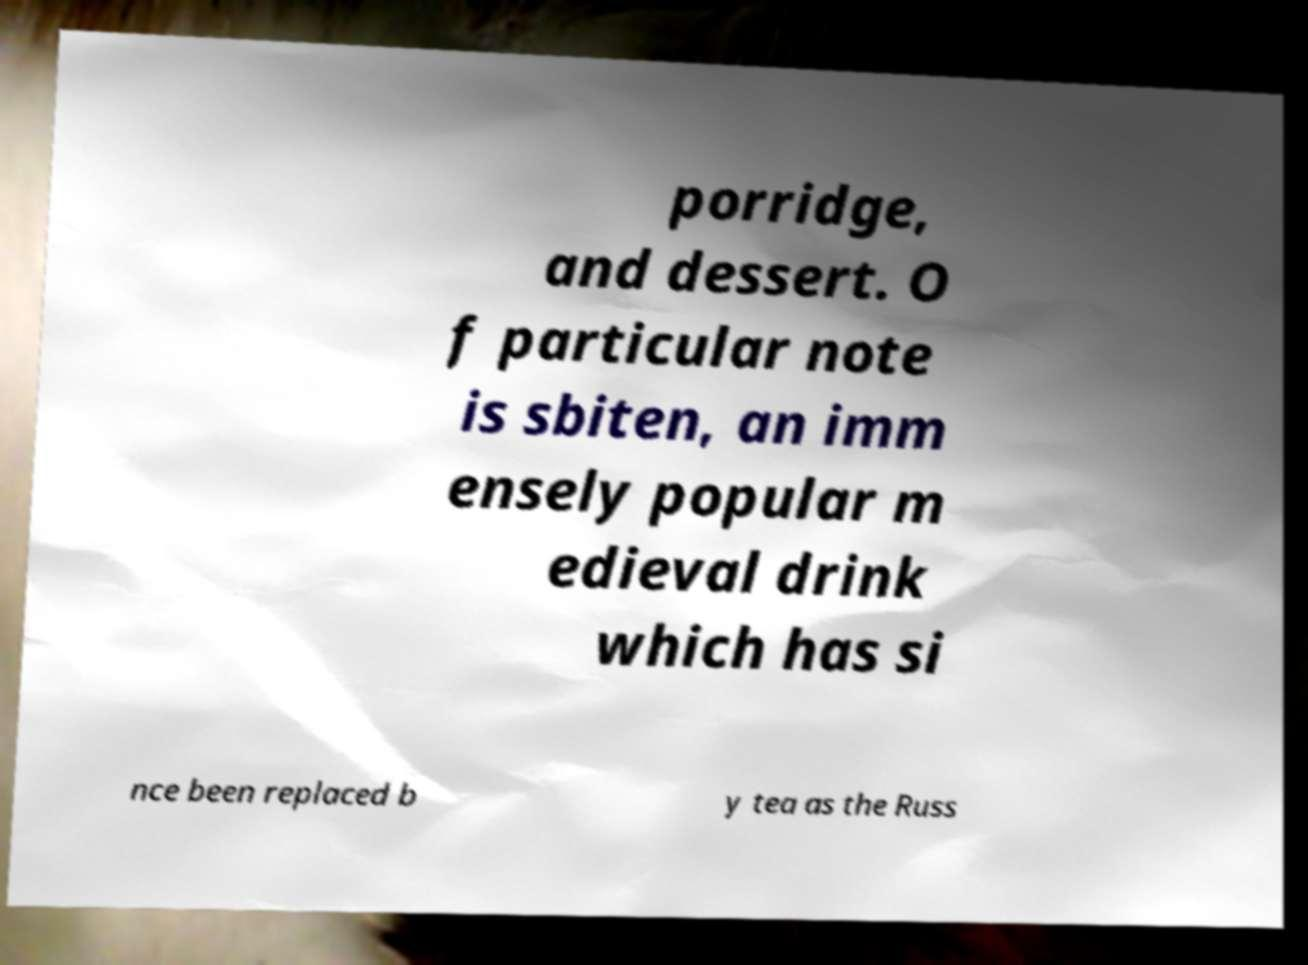What messages or text are displayed in this image? I need them in a readable, typed format. porridge, and dessert. O f particular note is sbiten, an imm ensely popular m edieval drink which has si nce been replaced b y tea as the Russ 